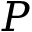Convert formula to latex. <formula><loc_0><loc_0><loc_500><loc_500>P</formula> 